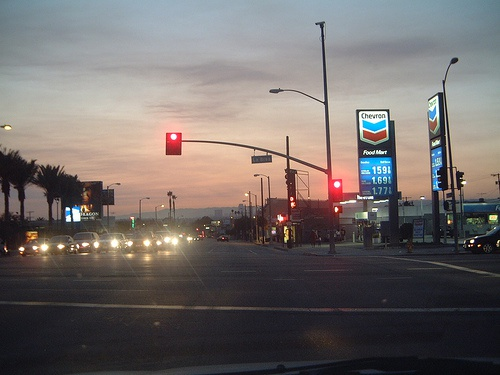Describe the objects in this image and their specific colors. I can see car in gray, black, blue, and navy tones, car in gray and tan tones, car in gray, tan, and ivory tones, car in gray, maroon, and tan tones, and traffic light in gray, brown, red, and salmon tones in this image. 